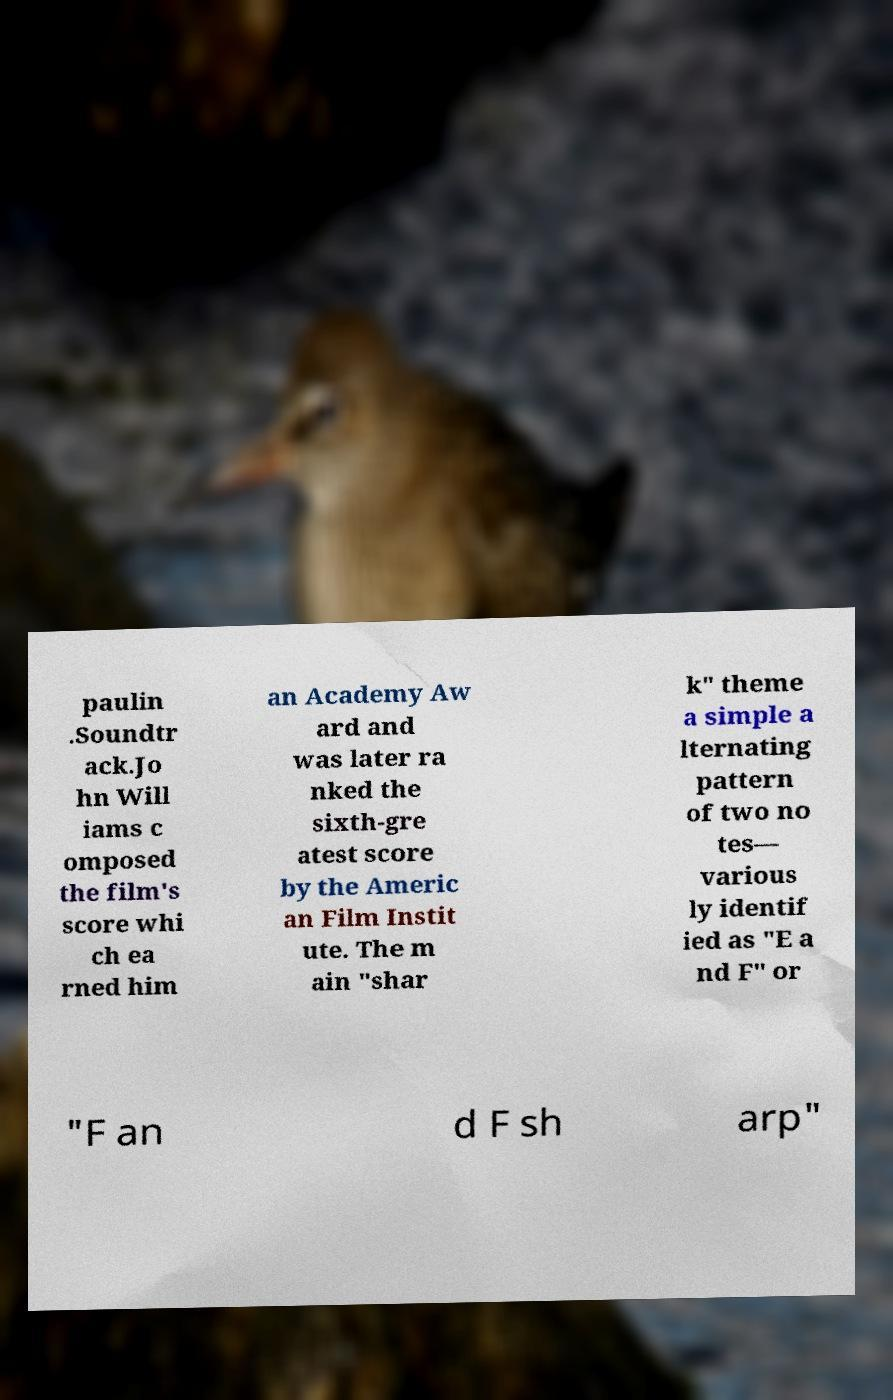There's text embedded in this image that I need extracted. Can you transcribe it verbatim? paulin .Soundtr ack.Jo hn Will iams c omposed the film's score whi ch ea rned him an Academy Aw ard and was later ra nked the sixth-gre atest score by the Americ an Film Instit ute. The m ain "shar k" theme a simple a lternating pattern of two no tes— various ly identif ied as "E a nd F" or "F an d F sh arp" 